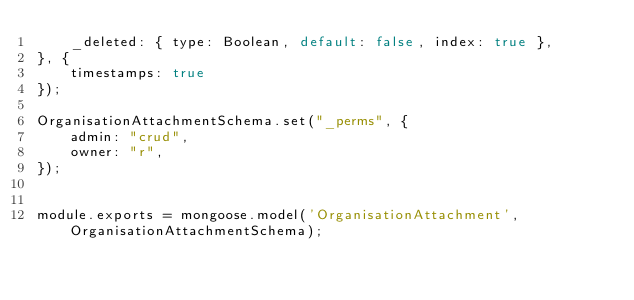<code> <loc_0><loc_0><loc_500><loc_500><_JavaScript_>	_deleted: { type: Boolean, default: false, index: true },
}, {
	timestamps: true
});

OrganisationAttachmentSchema.set("_perms", {
	admin: "crud",
	owner: "r",
});


module.exports = mongoose.model('OrganisationAttachment', OrganisationAttachmentSchema);
</code> 